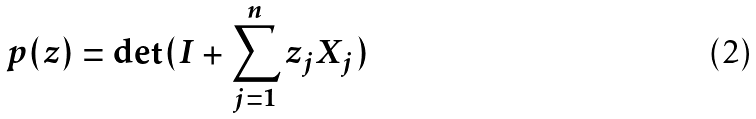Convert formula to latex. <formula><loc_0><loc_0><loc_500><loc_500>p ( z ) = \det ( I + \sum _ { j = 1 } ^ { n } z _ { j } X _ { j } )</formula> 